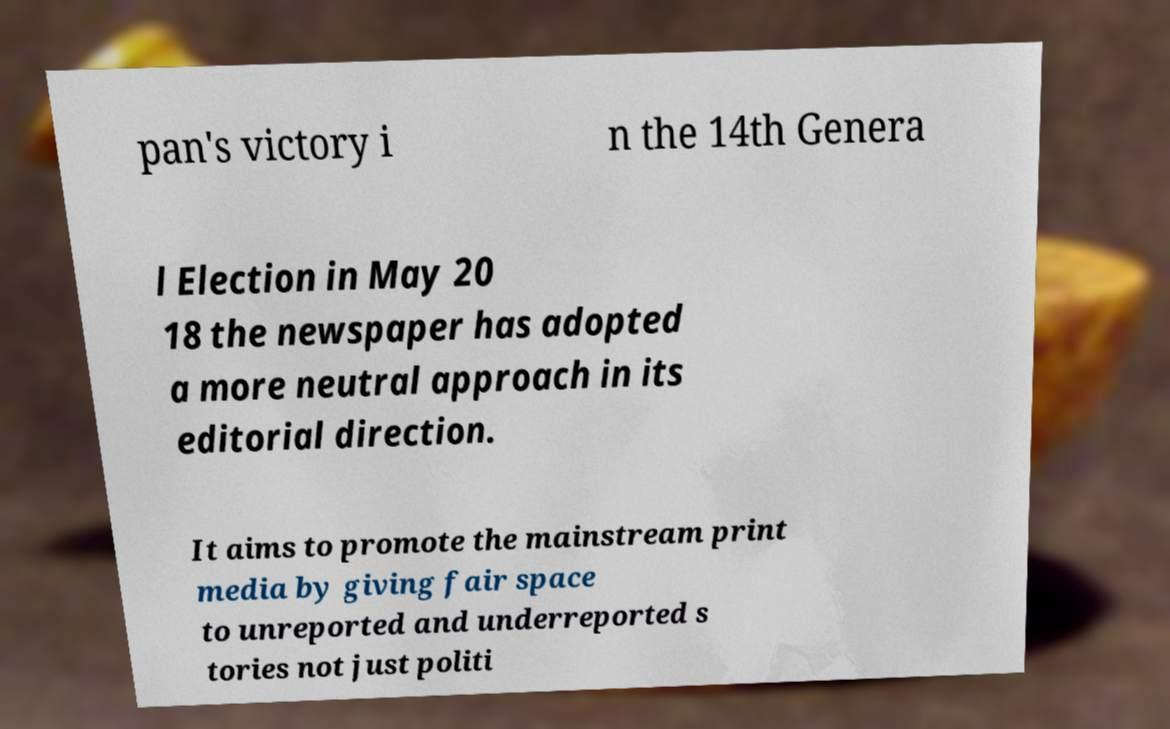Please read and relay the text visible in this image. What does it say? pan's victory i n the 14th Genera l Election in May 20 18 the newspaper has adopted a more neutral approach in its editorial direction. It aims to promote the mainstream print media by giving fair space to unreported and underreported s tories not just politi 